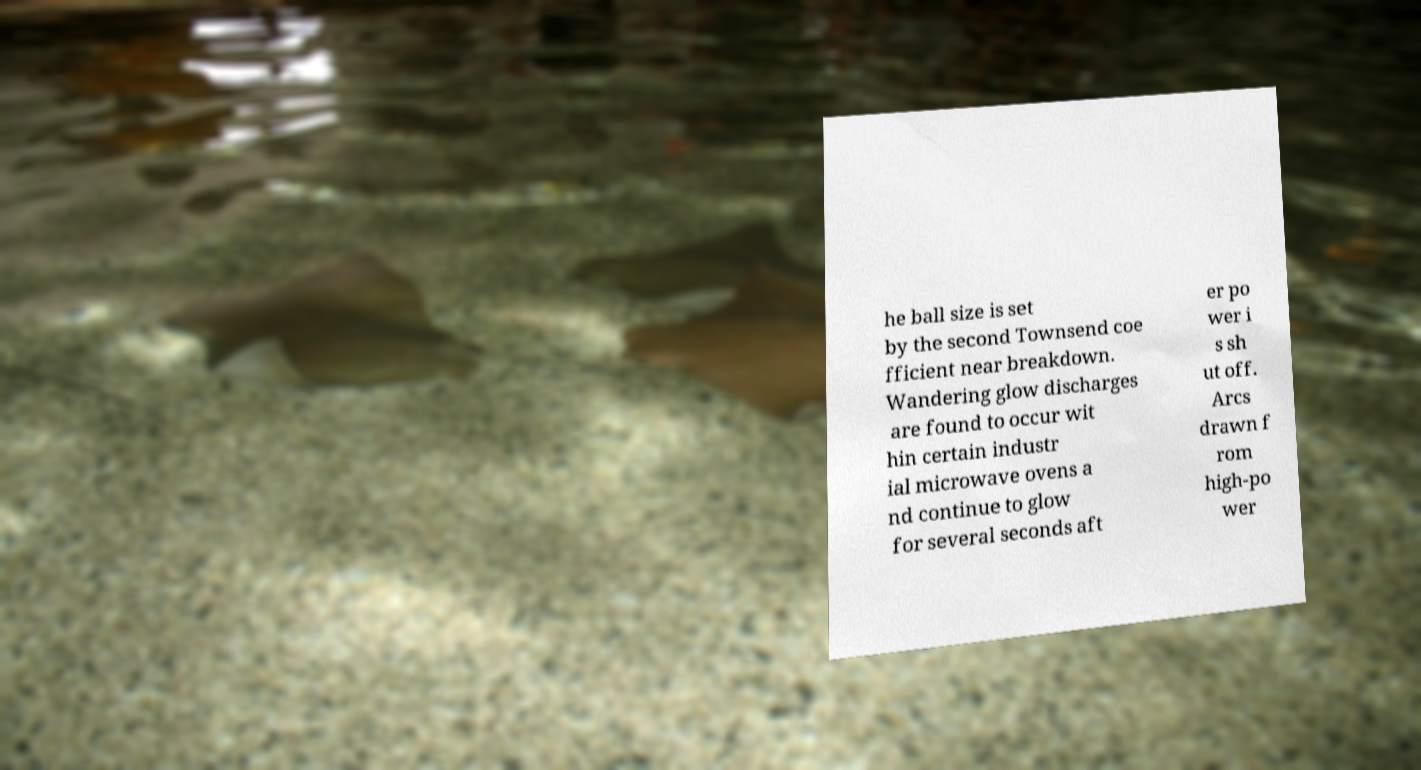I need the written content from this picture converted into text. Can you do that? he ball size is set by the second Townsend coe fficient near breakdown. Wandering glow discharges are found to occur wit hin certain industr ial microwave ovens a nd continue to glow for several seconds aft er po wer i s sh ut off. Arcs drawn f rom high-po wer 